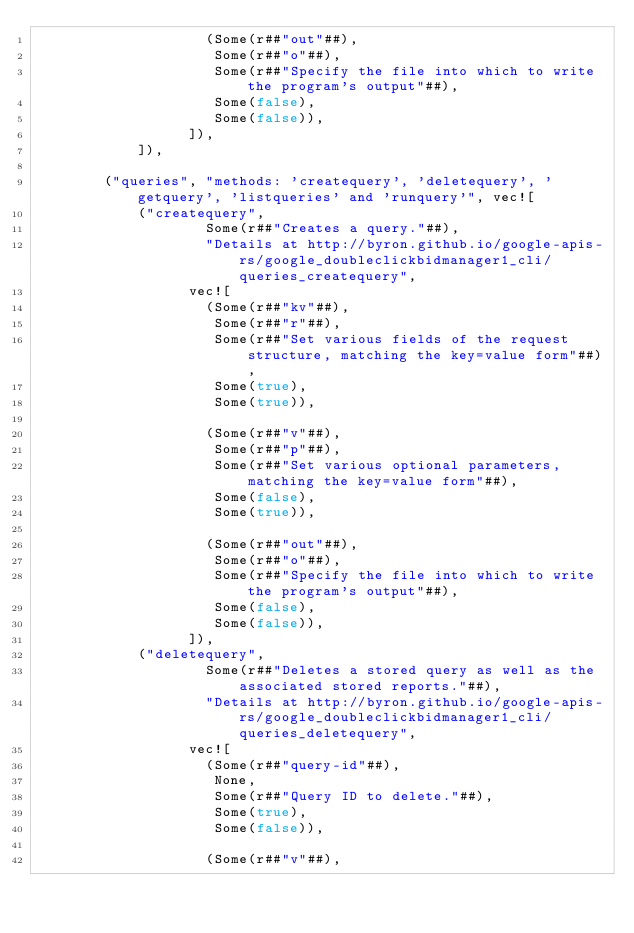<code> <loc_0><loc_0><loc_500><loc_500><_Rust_>                    (Some(r##"out"##),
                     Some(r##"o"##),
                     Some(r##"Specify the file into which to write the program's output"##),
                     Some(false),
                     Some(false)),
                  ]),
            ]),
        
        ("queries", "methods: 'createquery', 'deletequery', 'getquery', 'listqueries' and 'runquery'", vec![
            ("createquery",
                    Some(r##"Creates a query."##),
                    "Details at http://byron.github.io/google-apis-rs/google_doubleclickbidmanager1_cli/queries_createquery",
                  vec![
                    (Some(r##"kv"##),
                     Some(r##"r"##),
                     Some(r##"Set various fields of the request structure, matching the key=value form"##),
                     Some(true),
                     Some(true)),
        
                    (Some(r##"v"##),
                     Some(r##"p"##),
                     Some(r##"Set various optional parameters, matching the key=value form"##),
                     Some(false),
                     Some(true)),
        
                    (Some(r##"out"##),
                     Some(r##"o"##),
                     Some(r##"Specify the file into which to write the program's output"##),
                     Some(false),
                     Some(false)),
                  ]),
            ("deletequery",
                    Some(r##"Deletes a stored query as well as the associated stored reports."##),
                    "Details at http://byron.github.io/google-apis-rs/google_doubleclickbidmanager1_cli/queries_deletequery",
                  vec![
                    (Some(r##"query-id"##),
                     None,
                     Some(r##"Query ID to delete."##),
                     Some(true),
                     Some(false)),
        
                    (Some(r##"v"##),</code> 